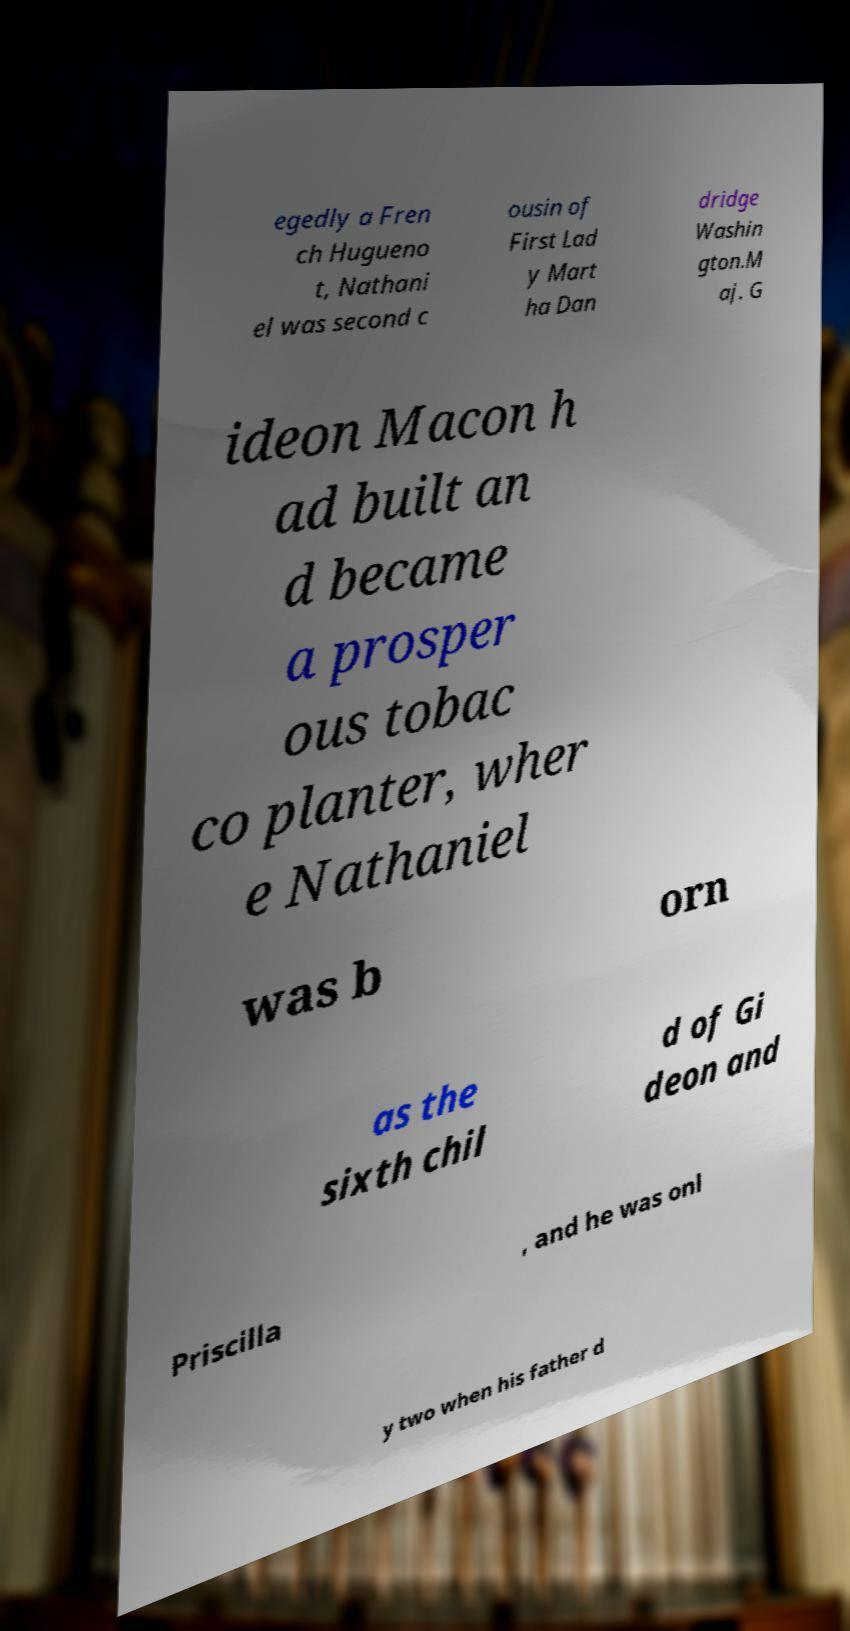I need the written content from this picture converted into text. Can you do that? egedly a Fren ch Hugueno t, Nathani el was second c ousin of First Lad y Mart ha Dan dridge Washin gton.M aj. G ideon Macon h ad built an d became a prosper ous tobac co planter, wher e Nathaniel was b orn as the sixth chil d of Gi deon and Priscilla , and he was onl y two when his father d 